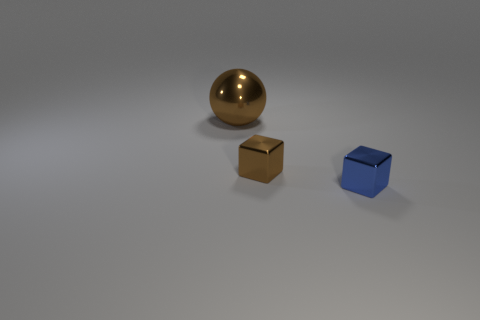Add 3 brown blocks. How many objects exist? 6 Subtract all brown blocks. How many blocks are left? 1 Subtract 1 spheres. How many spheres are left? 0 Subtract all large gray rubber objects. Subtract all cubes. How many objects are left? 1 Add 1 blue metal objects. How many blue metal objects are left? 2 Add 3 blue metallic blocks. How many blue metallic blocks exist? 4 Subtract 0 gray spheres. How many objects are left? 3 Subtract all balls. How many objects are left? 2 Subtract all yellow balls. Subtract all gray cubes. How many balls are left? 1 Subtract all blue cylinders. How many brown cubes are left? 1 